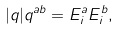<formula> <loc_0><loc_0><loc_500><loc_500>| q | q ^ { a b } = E ^ { a } _ { i } E ^ { b } _ { i } ,</formula> 